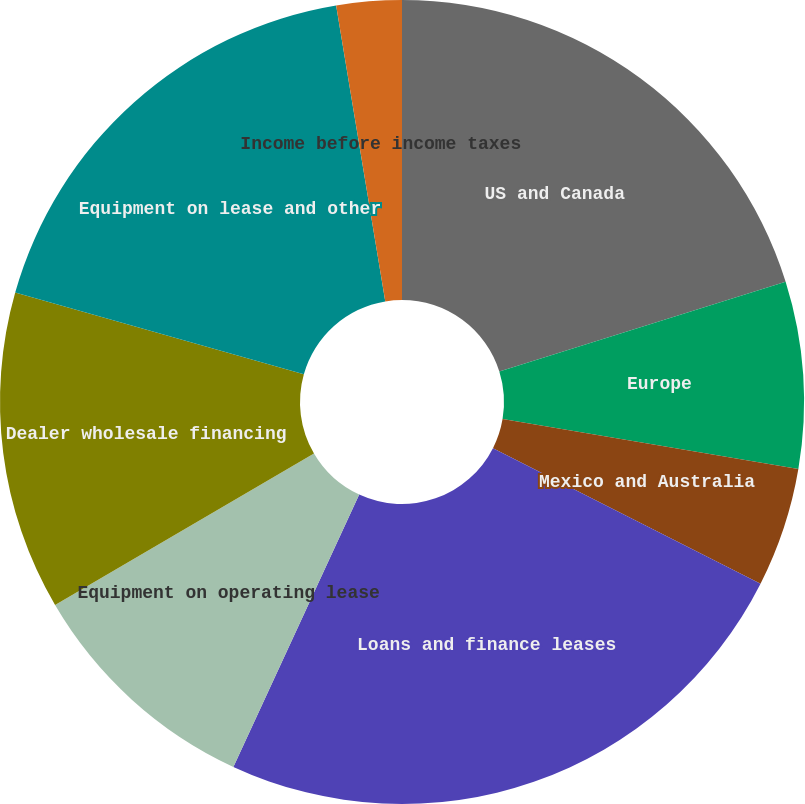Convert chart. <chart><loc_0><loc_0><loc_500><loc_500><pie_chart><fcel>US and Canada<fcel>Europe<fcel>Mexico and Australia<fcel>Loans and finance leases<fcel>Equipment on operating lease<fcel>Dealer wholesale financing<fcel>Equipment on lease and other<fcel>Income before income taxes<nl><fcel>20.17%<fcel>7.5%<fcel>4.8%<fcel>24.42%<fcel>9.68%<fcel>12.82%<fcel>17.99%<fcel>2.62%<nl></chart> 